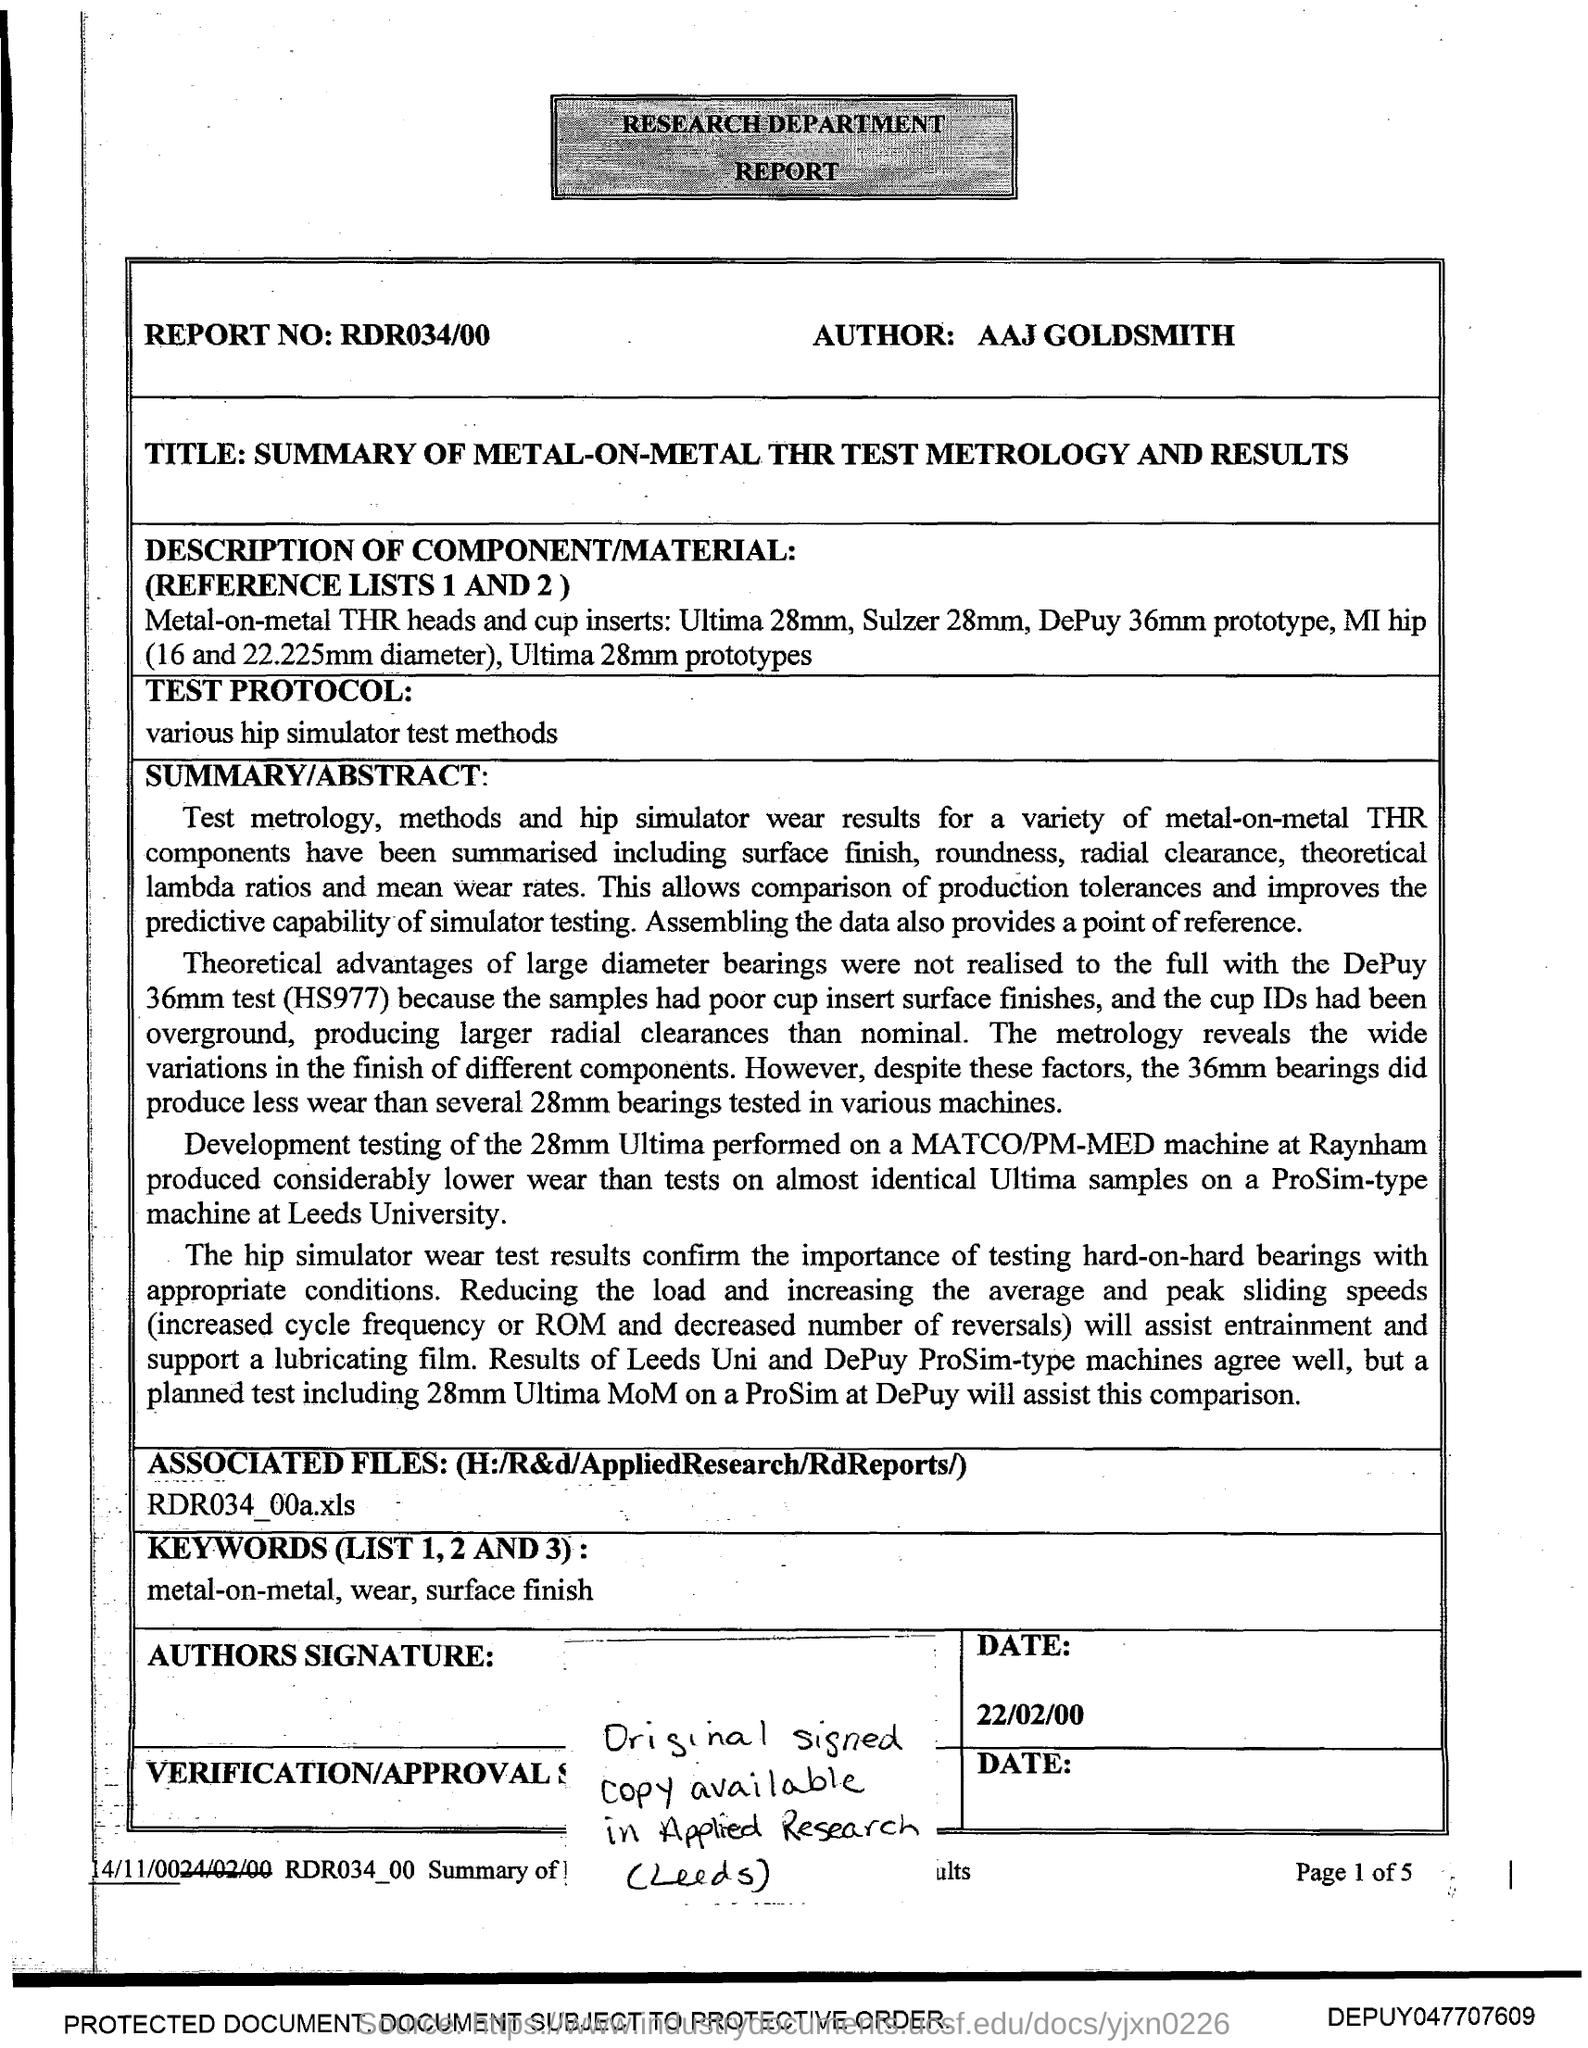Point out several critical features in this image. The author of this text is AAJ Goldsmith. The report number is RDR034/00... 